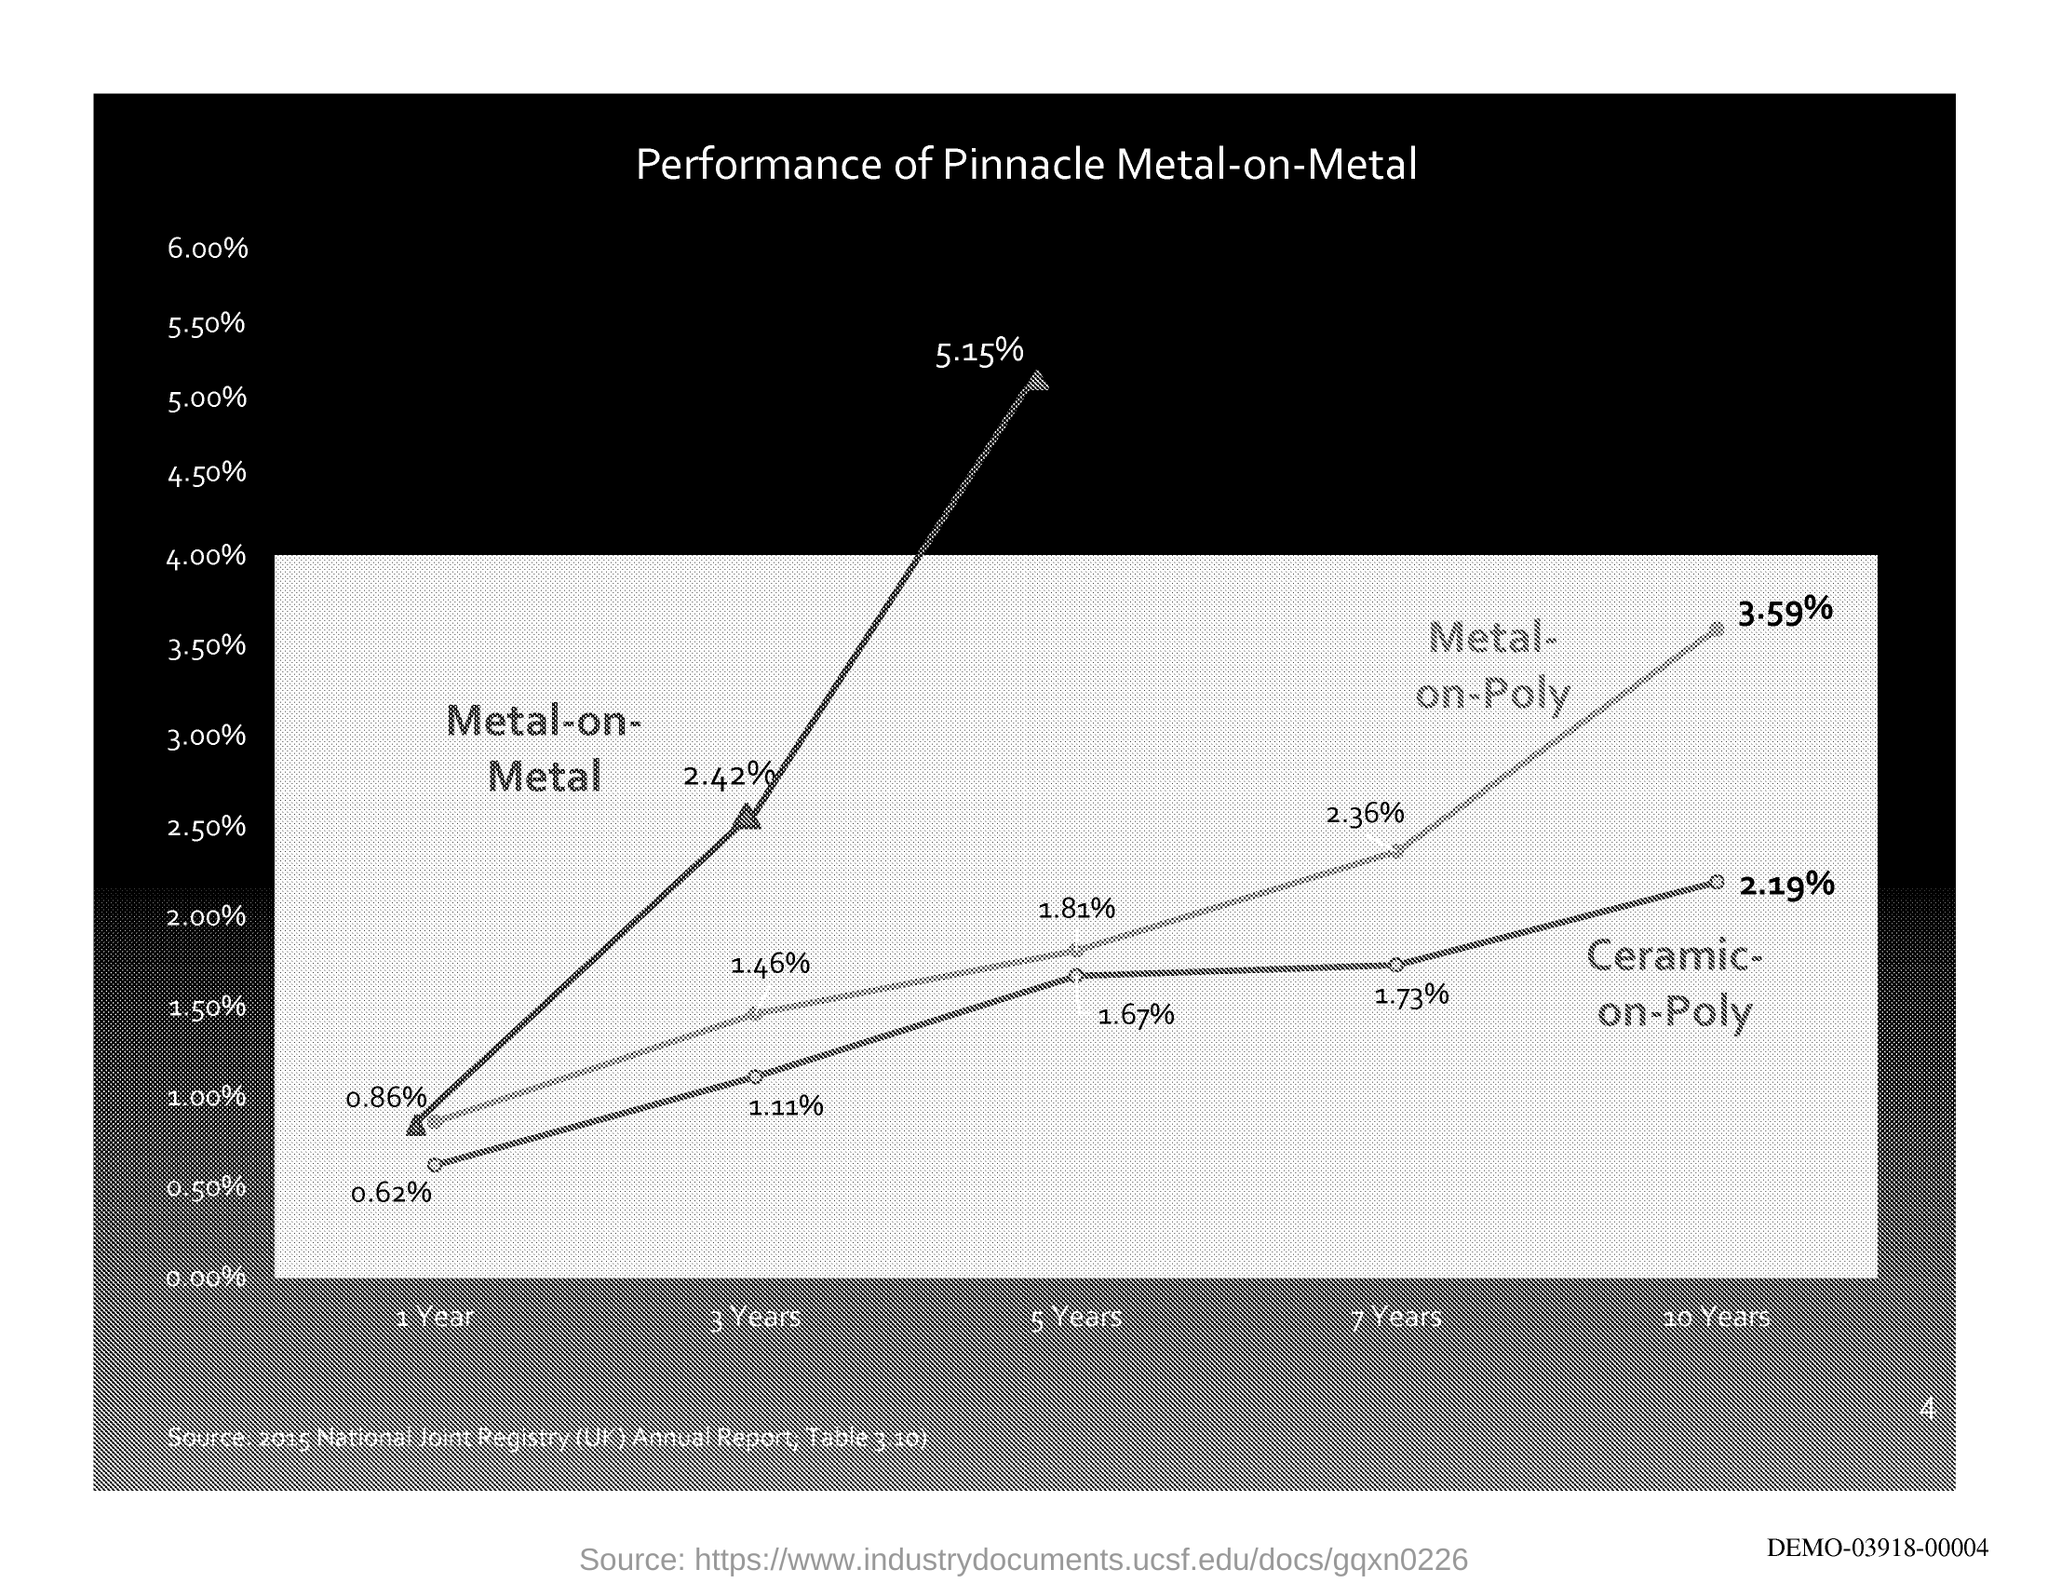Highlight a few significant elements in this photo. The source of the graph is the 2015 National Joint Registry (UK) Annual Report, as displayed in Table 3.10. The unit on the X-axis is years. What is the unit of the Y-axis in this graph? The title of the graph is "Performance of Pinnacle Metal-on-Metal Hip Implants Over Time. 